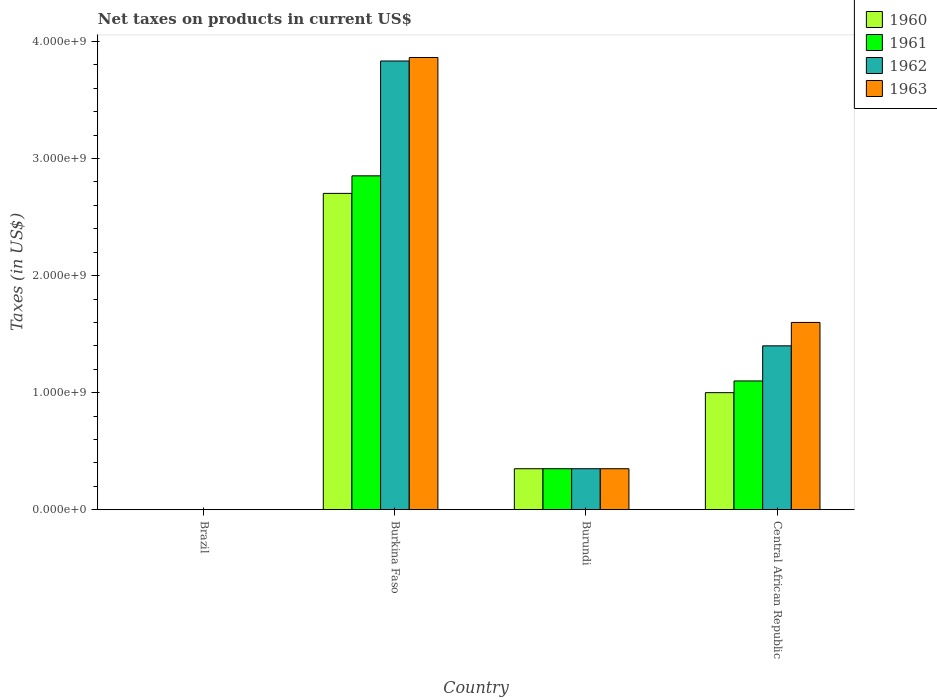How many different coloured bars are there?
Make the answer very short. 4. Are the number of bars per tick equal to the number of legend labels?
Provide a short and direct response. Yes. What is the label of the 4th group of bars from the left?
Provide a succinct answer. Central African Republic. In how many cases, is the number of bars for a given country not equal to the number of legend labels?
Provide a succinct answer. 0. What is the net taxes on products in 1960 in Brazil?
Ensure brevity in your answer.  0. Across all countries, what is the maximum net taxes on products in 1962?
Your answer should be compact. 3.83e+09. Across all countries, what is the minimum net taxes on products in 1961?
Your answer should be very brief. 0. In which country was the net taxes on products in 1961 maximum?
Your answer should be very brief. Burkina Faso. What is the total net taxes on products in 1962 in the graph?
Offer a very short reply. 5.58e+09. What is the difference between the net taxes on products in 1962 in Burkina Faso and that in Burundi?
Offer a very short reply. 3.48e+09. What is the difference between the net taxes on products in 1963 in Burkina Faso and the net taxes on products in 1962 in Brazil?
Offer a terse response. 3.86e+09. What is the average net taxes on products in 1960 per country?
Give a very brief answer. 1.01e+09. What is the difference between the net taxes on products of/in 1961 and net taxes on products of/in 1960 in Burundi?
Give a very brief answer. 0. In how many countries, is the net taxes on products in 1963 greater than 200000000 US$?
Make the answer very short. 3. What is the ratio of the net taxes on products in 1961 in Brazil to that in Central African Republic?
Offer a very short reply. 1.6707971208366253e-13. Is the net taxes on products in 1962 in Burkina Faso less than that in Burundi?
Provide a short and direct response. No. Is the difference between the net taxes on products in 1961 in Brazil and Central African Republic greater than the difference between the net taxes on products in 1960 in Brazil and Central African Republic?
Provide a short and direct response. No. What is the difference between the highest and the second highest net taxes on products in 1960?
Keep it short and to the point. -6.50e+08. What is the difference between the highest and the lowest net taxes on products in 1963?
Offer a terse response. 3.86e+09. Is it the case that in every country, the sum of the net taxes on products in 1962 and net taxes on products in 1963 is greater than the sum of net taxes on products in 1961 and net taxes on products in 1960?
Ensure brevity in your answer.  No. What does the 3rd bar from the right in Central African Republic represents?
Your answer should be very brief. 1961. How many countries are there in the graph?
Provide a short and direct response. 4. Are the values on the major ticks of Y-axis written in scientific E-notation?
Your answer should be very brief. Yes. Does the graph contain any zero values?
Your answer should be very brief. No. Does the graph contain grids?
Your response must be concise. No. How are the legend labels stacked?
Your answer should be very brief. Vertical. What is the title of the graph?
Keep it short and to the point. Net taxes on products in current US$. What is the label or title of the Y-axis?
Give a very brief answer. Taxes (in US$). What is the Taxes (in US$) in 1960 in Brazil?
Your response must be concise. 0. What is the Taxes (in US$) in 1961 in Brazil?
Your response must be concise. 0. What is the Taxes (in US$) of 1962 in Brazil?
Your response must be concise. 0. What is the Taxes (in US$) of 1963 in Brazil?
Keep it short and to the point. 0. What is the Taxes (in US$) in 1960 in Burkina Faso?
Your answer should be very brief. 2.70e+09. What is the Taxes (in US$) of 1961 in Burkina Faso?
Give a very brief answer. 2.85e+09. What is the Taxes (in US$) of 1962 in Burkina Faso?
Your answer should be compact. 3.83e+09. What is the Taxes (in US$) in 1963 in Burkina Faso?
Ensure brevity in your answer.  3.86e+09. What is the Taxes (in US$) of 1960 in Burundi?
Your response must be concise. 3.50e+08. What is the Taxes (in US$) in 1961 in Burundi?
Your response must be concise. 3.50e+08. What is the Taxes (in US$) in 1962 in Burundi?
Ensure brevity in your answer.  3.50e+08. What is the Taxes (in US$) in 1963 in Burundi?
Give a very brief answer. 3.50e+08. What is the Taxes (in US$) of 1960 in Central African Republic?
Provide a succinct answer. 1.00e+09. What is the Taxes (in US$) in 1961 in Central African Republic?
Give a very brief answer. 1.10e+09. What is the Taxes (in US$) of 1962 in Central African Republic?
Make the answer very short. 1.40e+09. What is the Taxes (in US$) in 1963 in Central African Republic?
Offer a very short reply. 1.60e+09. Across all countries, what is the maximum Taxes (in US$) of 1960?
Ensure brevity in your answer.  2.70e+09. Across all countries, what is the maximum Taxes (in US$) of 1961?
Provide a succinct answer. 2.85e+09. Across all countries, what is the maximum Taxes (in US$) of 1962?
Make the answer very short. 3.83e+09. Across all countries, what is the maximum Taxes (in US$) in 1963?
Your answer should be very brief. 3.86e+09. Across all countries, what is the minimum Taxes (in US$) of 1960?
Offer a very short reply. 0. Across all countries, what is the minimum Taxes (in US$) of 1961?
Make the answer very short. 0. Across all countries, what is the minimum Taxes (in US$) of 1962?
Provide a succinct answer. 0. Across all countries, what is the minimum Taxes (in US$) in 1963?
Give a very brief answer. 0. What is the total Taxes (in US$) of 1960 in the graph?
Give a very brief answer. 4.05e+09. What is the total Taxes (in US$) of 1961 in the graph?
Offer a very short reply. 4.30e+09. What is the total Taxes (in US$) in 1962 in the graph?
Provide a succinct answer. 5.58e+09. What is the total Taxes (in US$) of 1963 in the graph?
Your answer should be very brief. 5.81e+09. What is the difference between the Taxes (in US$) of 1960 in Brazil and that in Burkina Faso?
Offer a terse response. -2.70e+09. What is the difference between the Taxes (in US$) of 1961 in Brazil and that in Burkina Faso?
Your answer should be compact. -2.85e+09. What is the difference between the Taxes (in US$) of 1962 in Brazil and that in Burkina Faso?
Ensure brevity in your answer.  -3.83e+09. What is the difference between the Taxes (in US$) of 1963 in Brazil and that in Burkina Faso?
Give a very brief answer. -3.86e+09. What is the difference between the Taxes (in US$) of 1960 in Brazil and that in Burundi?
Your answer should be compact. -3.50e+08. What is the difference between the Taxes (in US$) in 1961 in Brazil and that in Burundi?
Your response must be concise. -3.50e+08. What is the difference between the Taxes (in US$) in 1962 in Brazil and that in Burundi?
Your answer should be very brief. -3.50e+08. What is the difference between the Taxes (in US$) in 1963 in Brazil and that in Burundi?
Offer a terse response. -3.50e+08. What is the difference between the Taxes (in US$) of 1960 in Brazil and that in Central African Republic?
Give a very brief answer. -1.00e+09. What is the difference between the Taxes (in US$) in 1961 in Brazil and that in Central African Republic?
Your answer should be very brief. -1.10e+09. What is the difference between the Taxes (in US$) in 1962 in Brazil and that in Central African Republic?
Provide a short and direct response. -1.40e+09. What is the difference between the Taxes (in US$) in 1963 in Brazil and that in Central African Republic?
Your response must be concise. -1.60e+09. What is the difference between the Taxes (in US$) of 1960 in Burkina Faso and that in Burundi?
Offer a terse response. 2.35e+09. What is the difference between the Taxes (in US$) of 1961 in Burkina Faso and that in Burundi?
Offer a terse response. 2.50e+09. What is the difference between the Taxes (in US$) in 1962 in Burkina Faso and that in Burundi?
Give a very brief answer. 3.48e+09. What is the difference between the Taxes (in US$) in 1963 in Burkina Faso and that in Burundi?
Offer a terse response. 3.51e+09. What is the difference between the Taxes (in US$) in 1960 in Burkina Faso and that in Central African Republic?
Provide a short and direct response. 1.70e+09. What is the difference between the Taxes (in US$) in 1961 in Burkina Faso and that in Central African Republic?
Offer a terse response. 1.75e+09. What is the difference between the Taxes (in US$) in 1962 in Burkina Faso and that in Central African Republic?
Offer a very short reply. 2.43e+09. What is the difference between the Taxes (in US$) in 1963 in Burkina Faso and that in Central African Republic?
Keep it short and to the point. 2.26e+09. What is the difference between the Taxes (in US$) in 1960 in Burundi and that in Central African Republic?
Make the answer very short. -6.50e+08. What is the difference between the Taxes (in US$) in 1961 in Burundi and that in Central African Republic?
Give a very brief answer. -7.50e+08. What is the difference between the Taxes (in US$) in 1962 in Burundi and that in Central African Republic?
Keep it short and to the point. -1.05e+09. What is the difference between the Taxes (in US$) of 1963 in Burundi and that in Central African Republic?
Make the answer very short. -1.25e+09. What is the difference between the Taxes (in US$) in 1960 in Brazil and the Taxes (in US$) in 1961 in Burkina Faso?
Give a very brief answer. -2.85e+09. What is the difference between the Taxes (in US$) of 1960 in Brazil and the Taxes (in US$) of 1962 in Burkina Faso?
Your response must be concise. -3.83e+09. What is the difference between the Taxes (in US$) in 1960 in Brazil and the Taxes (in US$) in 1963 in Burkina Faso?
Offer a very short reply. -3.86e+09. What is the difference between the Taxes (in US$) in 1961 in Brazil and the Taxes (in US$) in 1962 in Burkina Faso?
Your response must be concise. -3.83e+09. What is the difference between the Taxes (in US$) of 1961 in Brazil and the Taxes (in US$) of 1963 in Burkina Faso?
Give a very brief answer. -3.86e+09. What is the difference between the Taxes (in US$) of 1962 in Brazil and the Taxes (in US$) of 1963 in Burkina Faso?
Provide a short and direct response. -3.86e+09. What is the difference between the Taxes (in US$) of 1960 in Brazil and the Taxes (in US$) of 1961 in Burundi?
Provide a short and direct response. -3.50e+08. What is the difference between the Taxes (in US$) of 1960 in Brazil and the Taxes (in US$) of 1962 in Burundi?
Make the answer very short. -3.50e+08. What is the difference between the Taxes (in US$) in 1960 in Brazil and the Taxes (in US$) in 1963 in Burundi?
Your response must be concise. -3.50e+08. What is the difference between the Taxes (in US$) in 1961 in Brazil and the Taxes (in US$) in 1962 in Burundi?
Your response must be concise. -3.50e+08. What is the difference between the Taxes (in US$) of 1961 in Brazil and the Taxes (in US$) of 1963 in Burundi?
Make the answer very short. -3.50e+08. What is the difference between the Taxes (in US$) of 1962 in Brazil and the Taxes (in US$) of 1963 in Burundi?
Give a very brief answer. -3.50e+08. What is the difference between the Taxes (in US$) of 1960 in Brazil and the Taxes (in US$) of 1961 in Central African Republic?
Ensure brevity in your answer.  -1.10e+09. What is the difference between the Taxes (in US$) in 1960 in Brazil and the Taxes (in US$) in 1962 in Central African Republic?
Keep it short and to the point. -1.40e+09. What is the difference between the Taxes (in US$) in 1960 in Brazil and the Taxes (in US$) in 1963 in Central African Republic?
Your answer should be very brief. -1.60e+09. What is the difference between the Taxes (in US$) of 1961 in Brazil and the Taxes (in US$) of 1962 in Central African Republic?
Your answer should be compact. -1.40e+09. What is the difference between the Taxes (in US$) in 1961 in Brazil and the Taxes (in US$) in 1963 in Central African Republic?
Keep it short and to the point. -1.60e+09. What is the difference between the Taxes (in US$) in 1962 in Brazil and the Taxes (in US$) in 1963 in Central African Republic?
Keep it short and to the point. -1.60e+09. What is the difference between the Taxes (in US$) of 1960 in Burkina Faso and the Taxes (in US$) of 1961 in Burundi?
Keep it short and to the point. 2.35e+09. What is the difference between the Taxes (in US$) of 1960 in Burkina Faso and the Taxes (in US$) of 1962 in Burundi?
Your answer should be very brief. 2.35e+09. What is the difference between the Taxes (in US$) of 1960 in Burkina Faso and the Taxes (in US$) of 1963 in Burundi?
Offer a terse response. 2.35e+09. What is the difference between the Taxes (in US$) of 1961 in Burkina Faso and the Taxes (in US$) of 1962 in Burundi?
Provide a short and direct response. 2.50e+09. What is the difference between the Taxes (in US$) of 1961 in Burkina Faso and the Taxes (in US$) of 1963 in Burundi?
Make the answer very short. 2.50e+09. What is the difference between the Taxes (in US$) of 1962 in Burkina Faso and the Taxes (in US$) of 1963 in Burundi?
Your response must be concise. 3.48e+09. What is the difference between the Taxes (in US$) of 1960 in Burkina Faso and the Taxes (in US$) of 1961 in Central African Republic?
Make the answer very short. 1.60e+09. What is the difference between the Taxes (in US$) of 1960 in Burkina Faso and the Taxes (in US$) of 1962 in Central African Republic?
Your answer should be very brief. 1.30e+09. What is the difference between the Taxes (in US$) of 1960 in Burkina Faso and the Taxes (in US$) of 1963 in Central African Republic?
Keep it short and to the point. 1.10e+09. What is the difference between the Taxes (in US$) in 1961 in Burkina Faso and the Taxes (in US$) in 1962 in Central African Republic?
Give a very brief answer. 1.45e+09. What is the difference between the Taxes (in US$) of 1961 in Burkina Faso and the Taxes (in US$) of 1963 in Central African Republic?
Keep it short and to the point. 1.25e+09. What is the difference between the Taxes (in US$) of 1962 in Burkina Faso and the Taxes (in US$) of 1963 in Central African Republic?
Provide a succinct answer. 2.23e+09. What is the difference between the Taxes (in US$) of 1960 in Burundi and the Taxes (in US$) of 1961 in Central African Republic?
Offer a terse response. -7.50e+08. What is the difference between the Taxes (in US$) in 1960 in Burundi and the Taxes (in US$) in 1962 in Central African Republic?
Keep it short and to the point. -1.05e+09. What is the difference between the Taxes (in US$) in 1960 in Burundi and the Taxes (in US$) in 1963 in Central African Republic?
Make the answer very short. -1.25e+09. What is the difference between the Taxes (in US$) in 1961 in Burundi and the Taxes (in US$) in 1962 in Central African Republic?
Make the answer very short. -1.05e+09. What is the difference between the Taxes (in US$) of 1961 in Burundi and the Taxes (in US$) of 1963 in Central African Republic?
Your answer should be very brief. -1.25e+09. What is the difference between the Taxes (in US$) in 1962 in Burundi and the Taxes (in US$) in 1963 in Central African Republic?
Offer a very short reply. -1.25e+09. What is the average Taxes (in US$) in 1960 per country?
Ensure brevity in your answer.  1.01e+09. What is the average Taxes (in US$) in 1961 per country?
Your answer should be very brief. 1.08e+09. What is the average Taxes (in US$) in 1962 per country?
Ensure brevity in your answer.  1.40e+09. What is the average Taxes (in US$) of 1963 per country?
Make the answer very short. 1.45e+09. What is the difference between the Taxes (in US$) of 1960 and Taxes (in US$) of 1962 in Brazil?
Provide a succinct answer. -0. What is the difference between the Taxes (in US$) of 1960 and Taxes (in US$) of 1963 in Brazil?
Offer a terse response. -0. What is the difference between the Taxes (in US$) of 1961 and Taxes (in US$) of 1962 in Brazil?
Ensure brevity in your answer.  -0. What is the difference between the Taxes (in US$) of 1961 and Taxes (in US$) of 1963 in Brazil?
Your answer should be very brief. -0. What is the difference between the Taxes (in US$) of 1962 and Taxes (in US$) of 1963 in Brazil?
Provide a succinct answer. -0. What is the difference between the Taxes (in US$) in 1960 and Taxes (in US$) in 1961 in Burkina Faso?
Provide a short and direct response. -1.50e+08. What is the difference between the Taxes (in US$) of 1960 and Taxes (in US$) of 1962 in Burkina Faso?
Offer a very short reply. -1.13e+09. What is the difference between the Taxes (in US$) of 1960 and Taxes (in US$) of 1963 in Burkina Faso?
Offer a very short reply. -1.16e+09. What is the difference between the Taxes (in US$) in 1961 and Taxes (in US$) in 1962 in Burkina Faso?
Your answer should be compact. -9.81e+08. What is the difference between the Taxes (in US$) of 1961 and Taxes (in US$) of 1963 in Burkina Faso?
Your response must be concise. -1.01e+09. What is the difference between the Taxes (in US$) of 1962 and Taxes (in US$) of 1963 in Burkina Faso?
Provide a short and direct response. -3.00e+07. What is the difference between the Taxes (in US$) of 1961 and Taxes (in US$) of 1962 in Burundi?
Ensure brevity in your answer.  0. What is the difference between the Taxes (in US$) of 1961 and Taxes (in US$) of 1963 in Burundi?
Offer a very short reply. 0. What is the difference between the Taxes (in US$) in 1962 and Taxes (in US$) in 1963 in Burundi?
Give a very brief answer. 0. What is the difference between the Taxes (in US$) in 1960 and Taxes (in US$) in 1961 in Central African Republic?
Ensure brevity in your answer.  -1.00e+08. What is the difference between the Taxes (in US$) of 1960 and Taxes (in US$) of 1962 in Central African Republic?
Provide a short and direct response. -4.00e+08. What is the difference between the Taxes (in US$) in 1960 and Taxes (in US$) in 1963 in Central African Republic?
Your answer should be compact. -6.00e+08. What is the difference between the Taxes (in US$) of 1961 and Taxes (in US$) of 1962 in Central African Republic?
Your response must be concise. -3.00e+08. What is the difference between the Taxes (in US$) in 1961 and Taxes (in US$) in 1963 in Central African Republic?
Ensure brevity in your answer.  -5.00e+08. What is the difference between the Taxes (in US$) of 1962 and Taxes (in US$) of 1963 in Central African Republic?
Your response must be concise. -2.00e+08. What is the ratio of the Taxes (in US$) in 1961 in Brazil to that in Burkina Faso?
Your answer should be compact. 0. What is the ratio of the Taxes (in US$) in 1962 in Brazil to that in Burkina Faso?
Your answer should be compact. 0. What is the ratio of the Taxes (in US$) in 1963 in Brazil to that in Burkina Faso?
Your response must be concise. 0. What is the ratio of the Taxes (in US$) of 1960 in Brazil to that in Burundi?
Provide a succinct answer. 0. What is the ratio of the Taxes (in US$) of 1961 in Brazil to that in Burundi?
Offer a very short reply. 0. What is the ratio of the Taxes (in US$) in 1960 in Brazil to that in Central African Republic?
Give a very brief answer. 0. What is the ratio of the Taxes (in US$) in 1963 in Brazil to that in Central African Republic?
Offer a terse response. 0. What is the ratio of the Taxes (in US$) of 1960 in Burkina Faso to that in Burundi?
Your answer should be compact. 7.72. What is the ratio of the Taxes (in US$) in 1961 in Burkina Faso to that in Burundi?
Your response must be concise. 8.15. What is the ratio of the Taxes (in US$) in 1962 in Burkina Faso to that in Burundi?
Your answer should be compact. 10.95. What is the ratio of the Taxes (in US$) in 1963 in Burkina Faso to that in Burundi?
Ensure brevity in your answer.  11.04. What is the ratio of the Taxes (in US$) of 1960 in Burkina Faso to that in Central African Republic?
Provide a succinct answer. 2.7. What is the ratio of the Taxes (in US$) of 1961 in Burkina Faso to that in Central African Republic?
Keep it short and to the point. 2.59. What is the ratio of the Taxes (in US$) of 1962 in Burkina Faso to that in Central African Republic?
Offer a terse response. 2.74. What is the ratio of the Taxes (in US$) of 1963 in Burkina Faso to that in Central African Republic?
Give a very brief answer. 2.41. What is the ratio of the Taxes (in US$) of 1961 in Burundi to that in Central African Republic?
Make the answer very short. 0.32. What is the ratio of the Taxes (in US$) of 1963 in Burundi to that in Central African Republic?
Offer a very short reply. 0.22. What is the difference between the highest and the second highest Taxes (in US$) of 1960?
Offer a very short reply. 1.70e+09. What is the difference between the highest and the second highest Taxes (in US$) in 1961?
Keep it short and to the point. 1.75e+09. What is the difference between the highest and the second highest Taxes (in US$) in 1962?
Make the answer very short. 2.43e+09. What is the difference between the highest and the second highest Taxes (in US$) in 1963?
Offer a very short reply. 2.26e+09. What is the difference between the highest and the lowest Taxes (in US$) in 1960?
Offer a very short reply. 2.70e+09. What is the difference between the highest and the lowest Taxes (in US$) of 1961?
Offer a very short reply. 2.85e+09. What is the difference between the highest and the lowest Taxes (in US$) of 1962?
Provide a short and direct response. 3.83e+09. What is the difference between the highest and the lowest Taxes (in US$) of 1963?
Ensure brevity in your answer.  3.86e+09. 